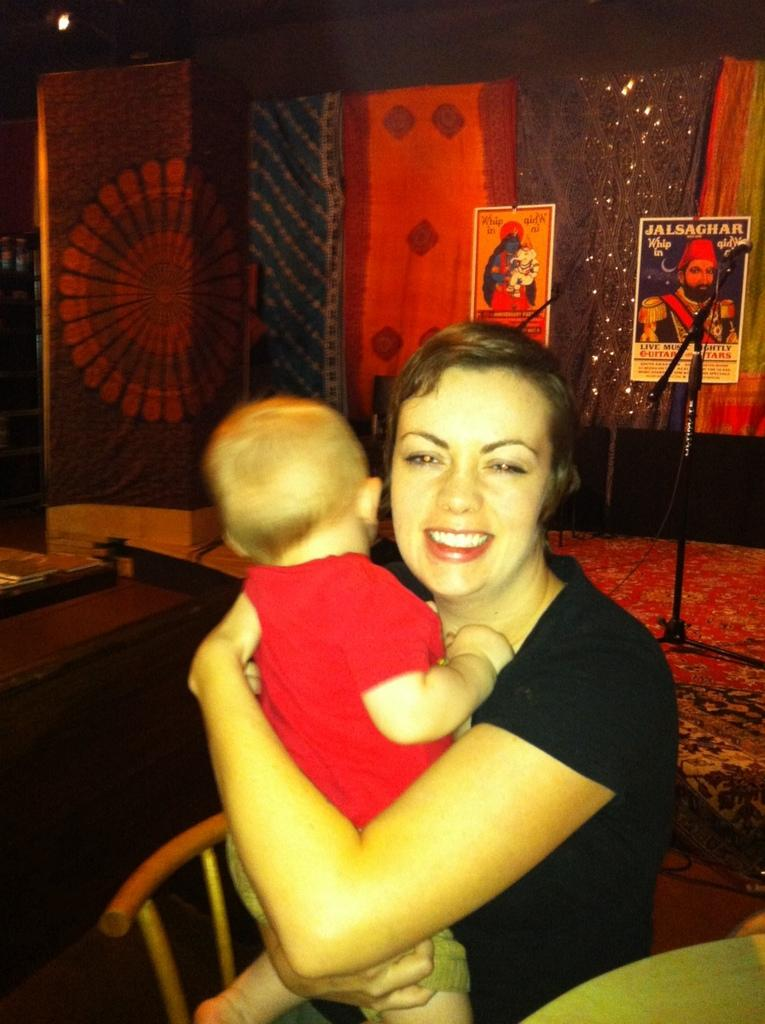Who is the main subject in the image? There is a woman in the image. What is the woman doing in the image? The woman is sitting and holding a kid. What can be seen in the background of the image? There is a microphone and two posters in the background of the image. What type of thumb is visible in the image? There is no thumb present in the image. What kind of structure is the woman working on in the image? The image does not show the woman working on any structure; she is holding a kid and sitting. 